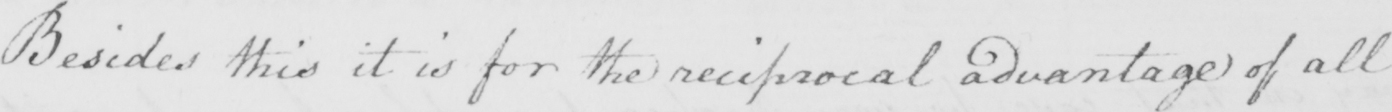Please provide the text content of this handwritten line. Besides this it is for the reciprocal advantage of all 